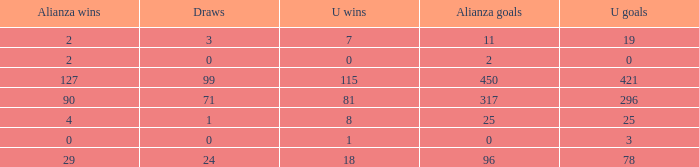What is the total number of U Wins, when Alianza Goals is "0", and when U Goals is greater than 3? 0.0. 